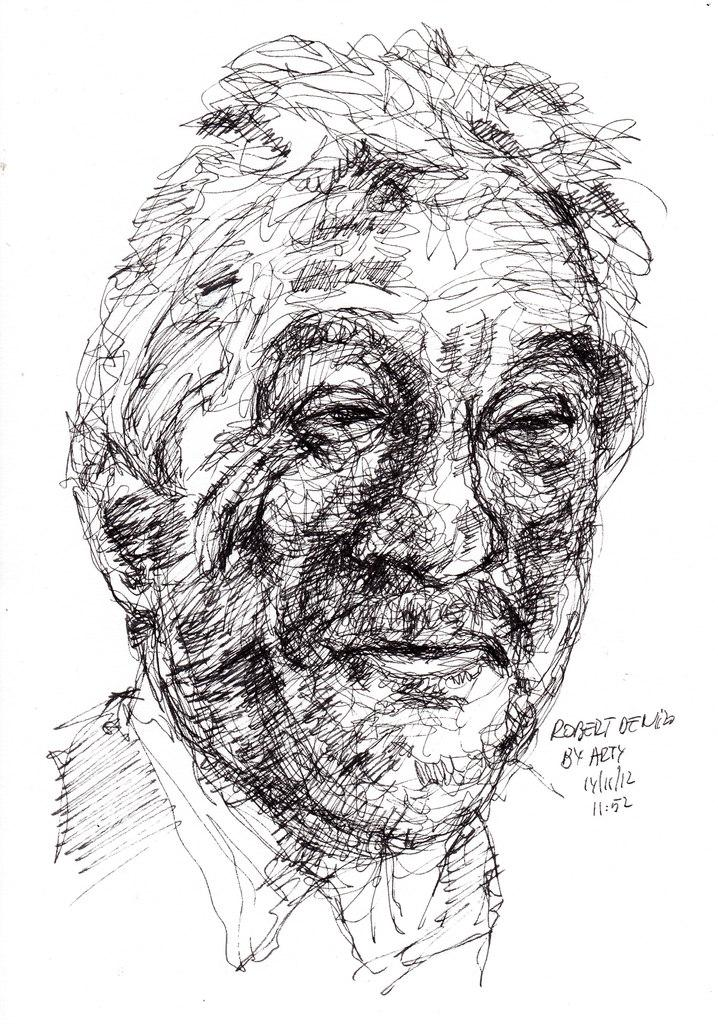What is the main subject of the image? The main subject of the image is a sketch of a man. Is there any text accompanying the sketch? Yes, there is some text in the image. What hobbies does the man in the sketch have? The image does not provide any information about the man's hobbies. How does the man's stomach look in the sketch? The image does not focus on the man's stomach, so it cannot be determined from the sketch. 